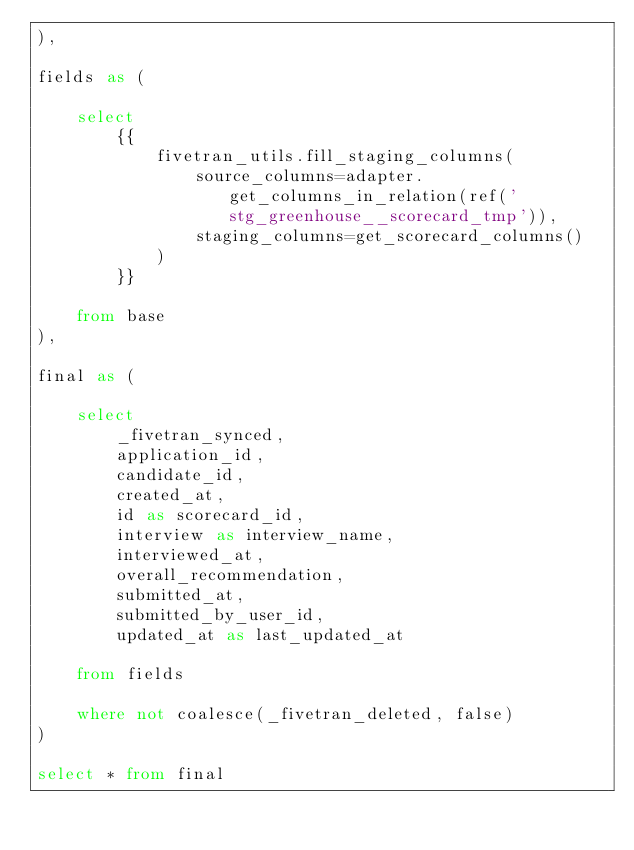<code> <loc_0><loc_0><loc_500><loc_500><_SQL_>),

fields as (

    select
        {{
            fivetran_utils.fill_staging_columns(
                source_columns=adapter.get_columns_in_relation(ref('stg_greenhouse__scorecard_tmp')),
                staging_columns=get_scorecard_columns()
            )
        }}
        
    from base
),

final as (
    
    select 
        _fivetran_synced,
        application_id,
        candidate_id,
        created_at,
        id as scorecard_id,
        interview as interview_name,
        interviewed_at,
        overall_recommendation,
        submitted_at,
        submitted_by_user_id,
        updated_at as last_updated_at

    from fields

    where not coalesce(_fivetran_deleted, false)
)

select * from final
</code> 